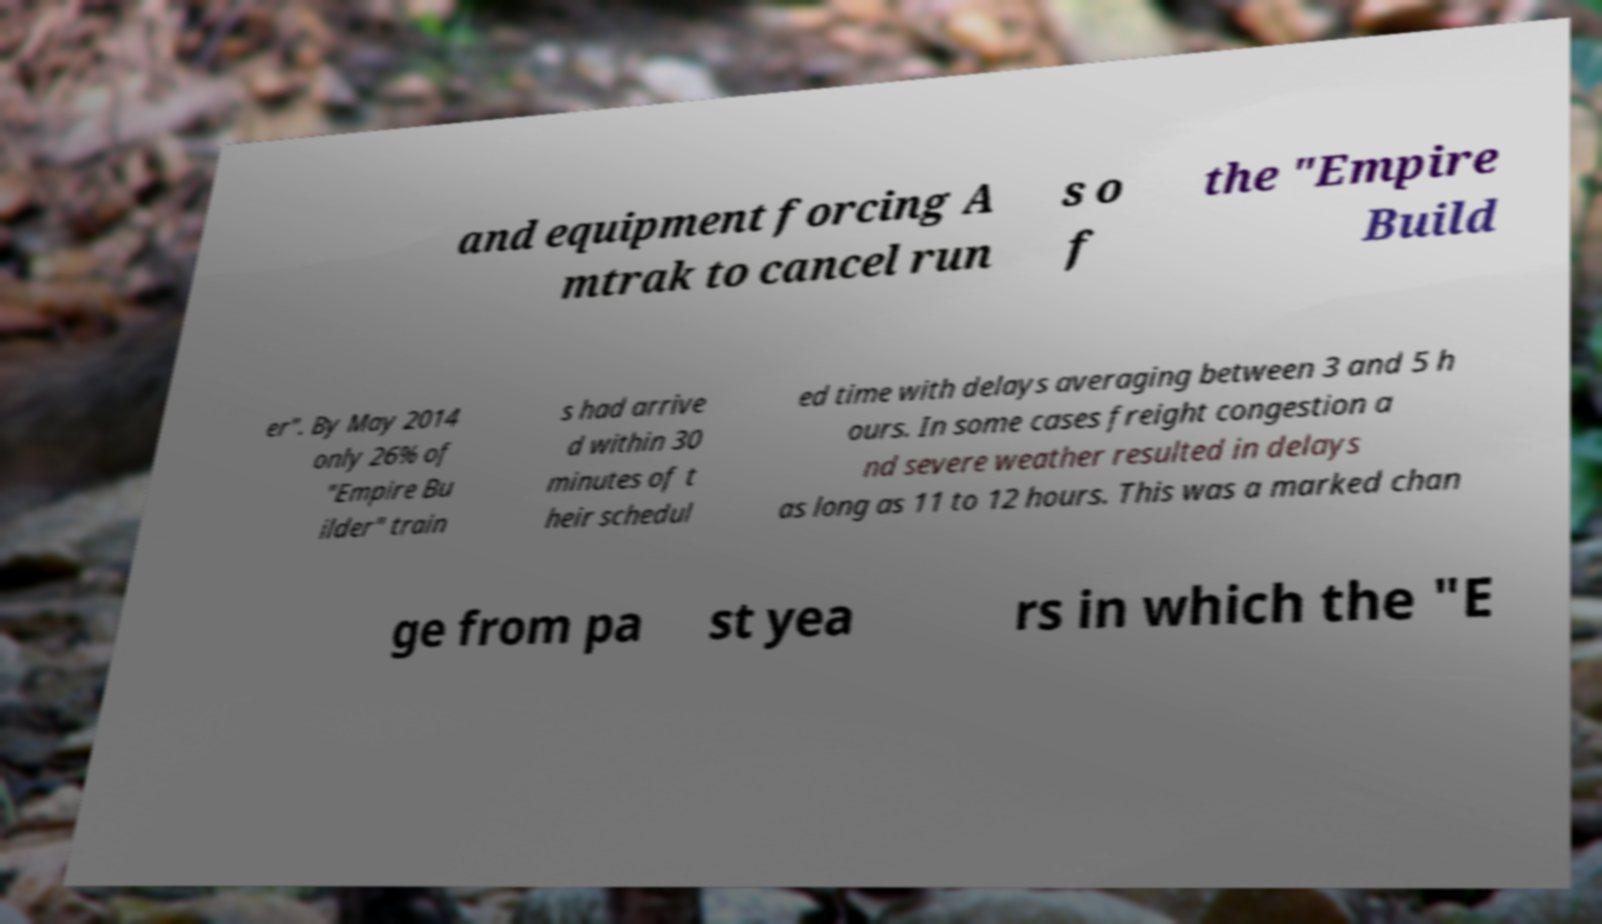Please read and relay the text visible in this image. What does it say? and equipment forcing A mtrak to cancel run s o f the "Empire Build er". By May 2014 only 26% of "Empire Bu ilder" train s had arrive d within 30 minutes of t heir schedul ed time with delays averaging between 3 and 5 h ours. In some cases freight congestion a nd severe weather resulted in delays as long as 11 to 12 hours. This was a marked chan ge from pa st yea rs in which the "E 